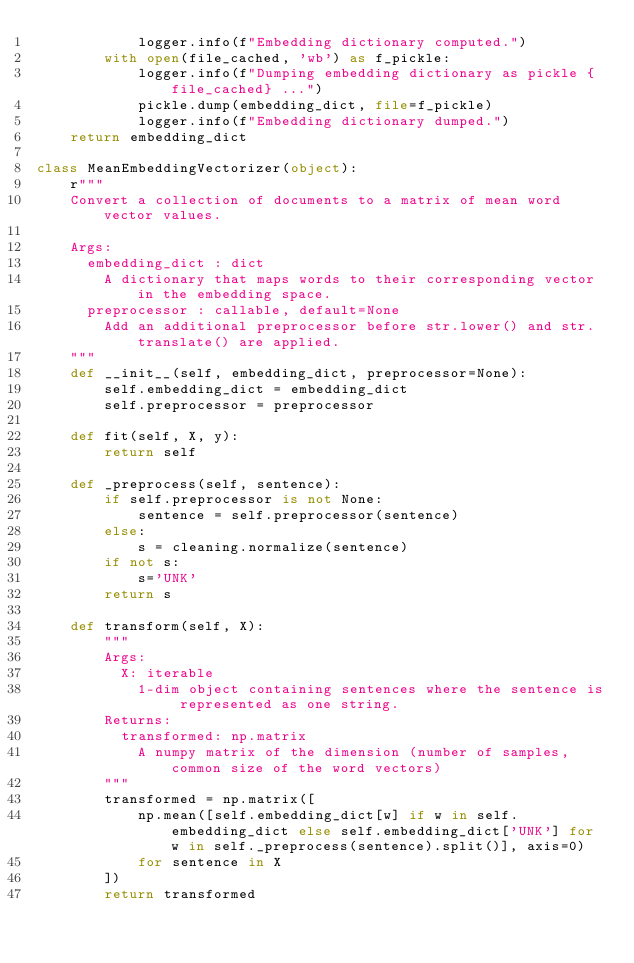Convert code to text. <code><loc_0><loc_0><loc_500><loc_500><_Python_>            logger.info(f"Embedding dictionary computed.")
        with open(file_cached, 'wb') as f_pickle:
            logger.info(f"Dumping embedding dictionary as pickle {file_cached} ...")
            pickle.dump(embedding_dict, file=f_pickle)
            logger.info(f"Embedding dictionary dumped.")
    return embedding_dict

class MeanEmbeddingVectorizer(object):
    r"""
    Convert a collection of documents to a matrix of mean word vector values.

    Args:
      embedding_dict : dict
        A dictionary that maps words to their corresponding vector in the embedding space.
      preprocessor : callable, default=None
        Add an additional preprocessor before str.lower() and str.translate() are applied.
    """
    def __init__(self, embedding_dict, preprocessor=None):
        self.embedding_dict = embedding_dict
        self.preprocessor = preprocessor

    def fit(self, X, y):
        return self
    
    def _preprocess(self, sentence):
        if self.preprocessor is not None:
            sentence = self.preprocessor(sentence)
        else:
            s = cleaning.normalize(sentence)
        if not s: 
            s='UNK'
        return s
        
    def transform(self, X):
        """
        Args: 
          X: iterable 
            1-dim object containing sentences where the sentence is represented as one string.
        Returns: 
          transformed: np.matrix
            A numpy matrix of the dimension (number of samples, common size of the word vectors)
        """
        transformed = np.matrix([
            np.mean([self.embedding_dict[w] if w in self.embedding_dict else self.embedding_dict['UNK'] for w in self._preprocess(sentence).split()], axis=0)
            for sentence in X
        ])
        return transformed</code> 